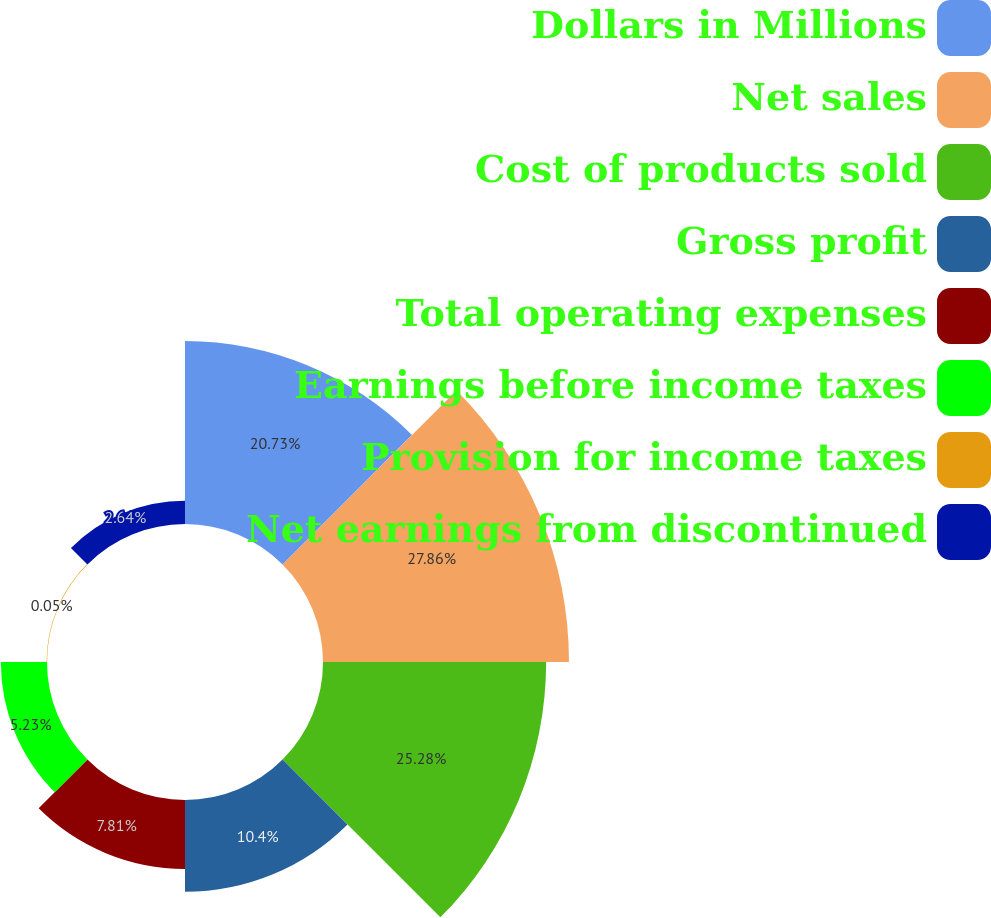<chart> <loc_0><loc_0><loc_500><loc_500><pie_chart><fcel>Dollars in Millions<fcel>Net sales<fcel>Cost of products sold<fcel>Gross profit<fcel>Total operating expenses<fcel>Earnings before income taxes<fcel>Provision for income taxes<fcel>Net earnings from discontinued<nl><fcel>20.73%<fcel>27.87%<fcel>25.28%<fcel>10.4%<fcel>7.81%<fcel>5.23%<fcel>0.05%<fcel>2.64%<nl></chart> 